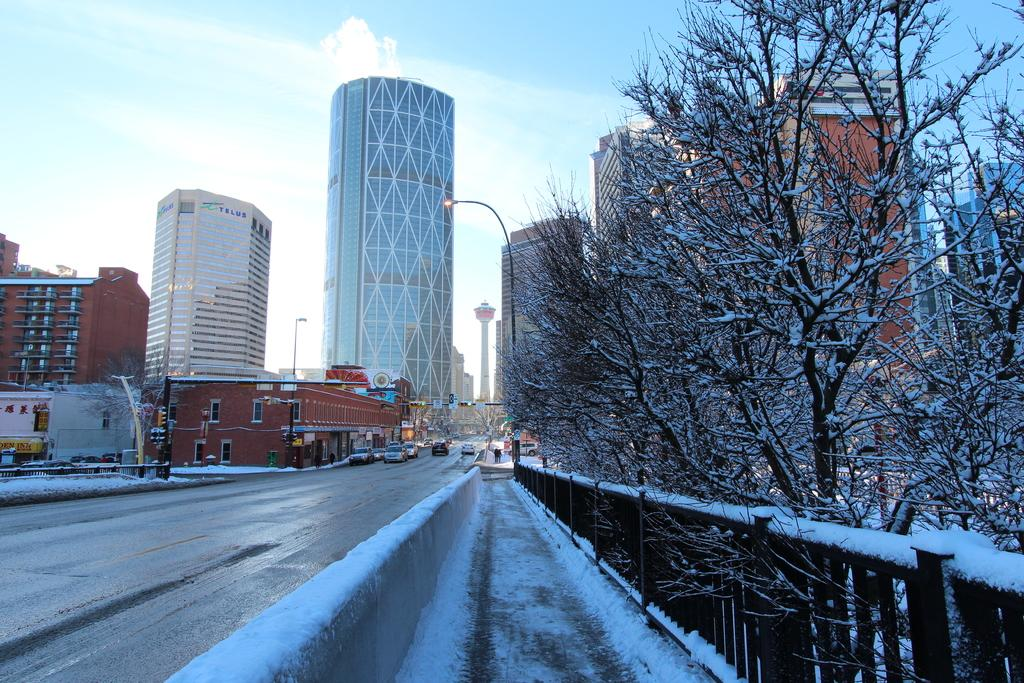What is located in the foreground of the image? In the foreground of the image, there is a fence, trees, light poles, buildings, and fleets of cars on the road. What can be seen in the background of the image? The sky is blue in the background of the image. Where was the image taken? The image was taken on the road. Can you see any wings on the cars in the image? There are no wings visible on the cars in the image. Is there a flame coming out of the trees in the image? There is no flame present in the image; it features a fence, trees, light poles, buildings, cars, and a blue sky. 